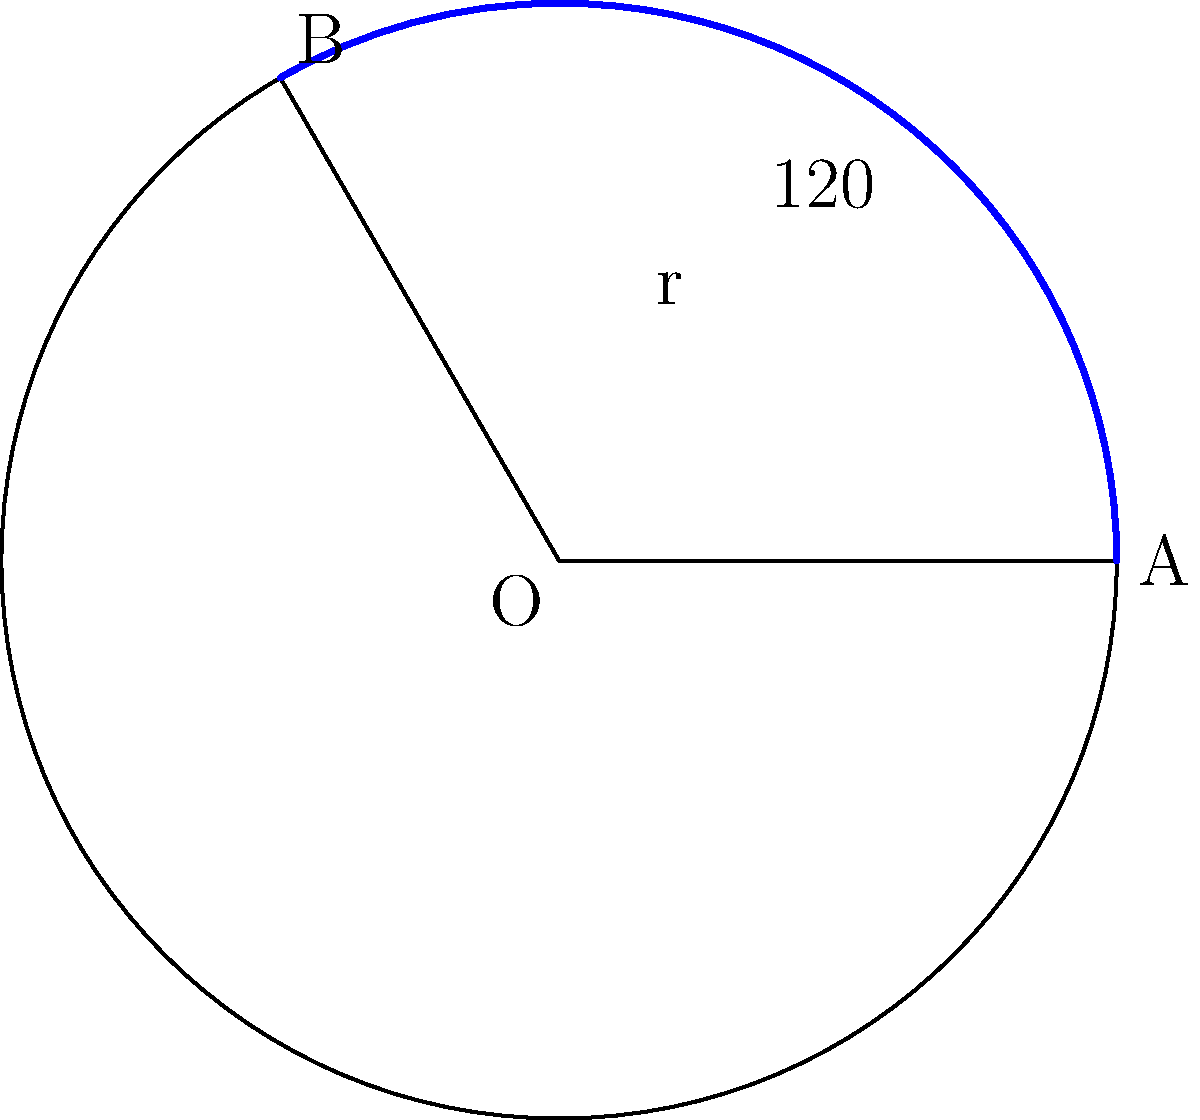You're planning a curved dolly track for a sweeping shot in your latest Scottish indie film. The track needs to follow an arc of a circle with radius 5 meters, spanning an angle of 120°. What is the length of the arc (in meters) that your dolly track needs to cover? To solve this problem, we'll use the formula for arc length:

$$ s = r\theta $$

Where:
- $s$ is the arc length
- $r$ is the radius of the circle
- $\theta$ is the central angle in radians

Step 1: Convert the angle from degrees to radians.
$$ \theta = 120° \times \frac{\pi}{180°} = \frac{2\pi}{3} \approx 2.0944 \text{ radians} $$

Step 2: Apply the arc length formula.
$$ s = r\theta = 5 \times \frac{2\pi}{3} = \frac{10\pi}{3} \approx 10.472 \text{ meters} $$

Therefore, the length of the arc that your dolly track needs to cover is approximately 10.472 meters.
Answer: $\frac{10\pi}{3}$ meters or approximately 10.472 meters 